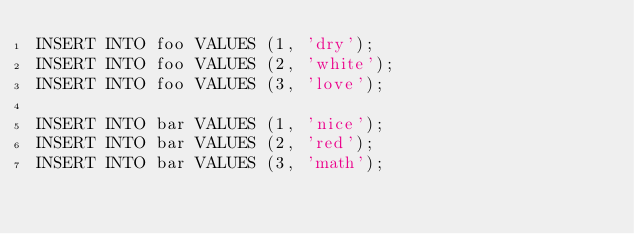<code> <loc_0><loc_0><loc_500><loc_500><_SQL_>INSERT INTO foo VALUES (1, 'dry');
INSERT INTO foo VALUES (2, 'white');
INSERT INTO foo VALUES (3, 'love');

INSERT INTO bar VALUES (1, 'nice');
INSERT INTO bar VALUES (2, 'red');
INSERT INTO bar VALUES (3, 'math');
</code> 